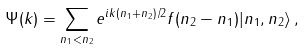<formula> <loc_0><loc_0><loc_500><loc_500>\Psi ( k ) = \sum _ { n _ { 1 } < n _ { 2 } } e ^ { i k ( n _ { 1 } + n _ { 2 } ) / 2 } f ( n _ { 2 } - n _ { 1 } ) | n _ { 1 } , n _ { 2 } \rangle \, ,</formula> 